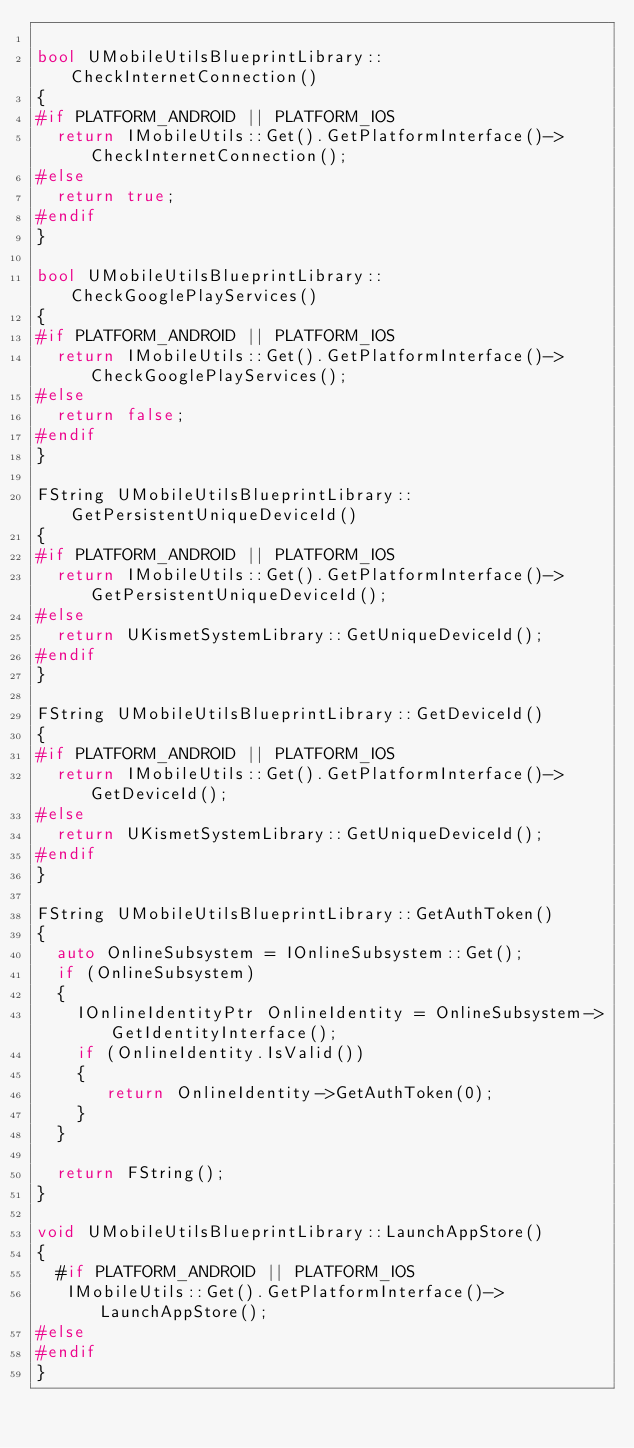Convert code to text. <code><loc_0><loc_0><loc_500><loc_500><_C++_>
bool UMobileUtilsBlueprintLibrary::CheckInternetConnection()
{
#if PLATFORM_ANDROID || PLATFORM_IOS
	return IMobileUtils::Get().GetPlatformInterface()->CheckInternetConnection();
#else
	return true;
#endif
}

bool UMobileUtilsBlueprintLibrary::CheckGooglePlayServices()
{
#if PLATFORM_ANDROID || PLATFORM_IOS
	return IMobileUtils::Get().GetPlatformInterface()->CheckGooglePlayServices();
#else
	return false;
#endif
}

FString UMobileUtilsBlueprintLibrary::GetPersistentUniqueDeviceId()
{
#if PLATFORM_ANDROID || PLATFORM_IOS
	return IMobileUtils::Get().GetPlatformInterface()->GetPersistentUniqueDeviceId();
#else
	return UKismetSystemLibrary::GetUniqueDeviceId();
#endif
}

FString UMobileUtilsBlueprintLibrary::GetDeviceId()
{
#if PLATFORM_ANDROID || PLATFORM_IOS
	return IMobileUtils::Get().GetPlatformInterface()->GetDeviceId();
#else
	return UKismetSystemLibrary::GetUniqueDeviceId();
#endif
}

FString UMobileUtilsBlueprintLibrary::GetAuthToken()
{
	auto OnlineSubsystem = IOnlineSubsystem::Get();
	if (OnlineSubsystem)
	{
		IOnlineIdentityPtr OnlineIdentity = OnlineSubsystem->GetIdentityInterface();
		if (OnlineIdentity.IsValid())
		{
			 return OnlineIdentity->GetAuthToken(0);
		}
	}

	return FString();
}

void UMobileUtilsBlueprintLibrary::LaunchAppStore()
{
	#if PLATFORM_ANDROID || PLATFORM_IOS
	 IMobileUtils::Get().GetPlatformInterface()->LaunchAppStore();
#else
#endif
}
</code> 